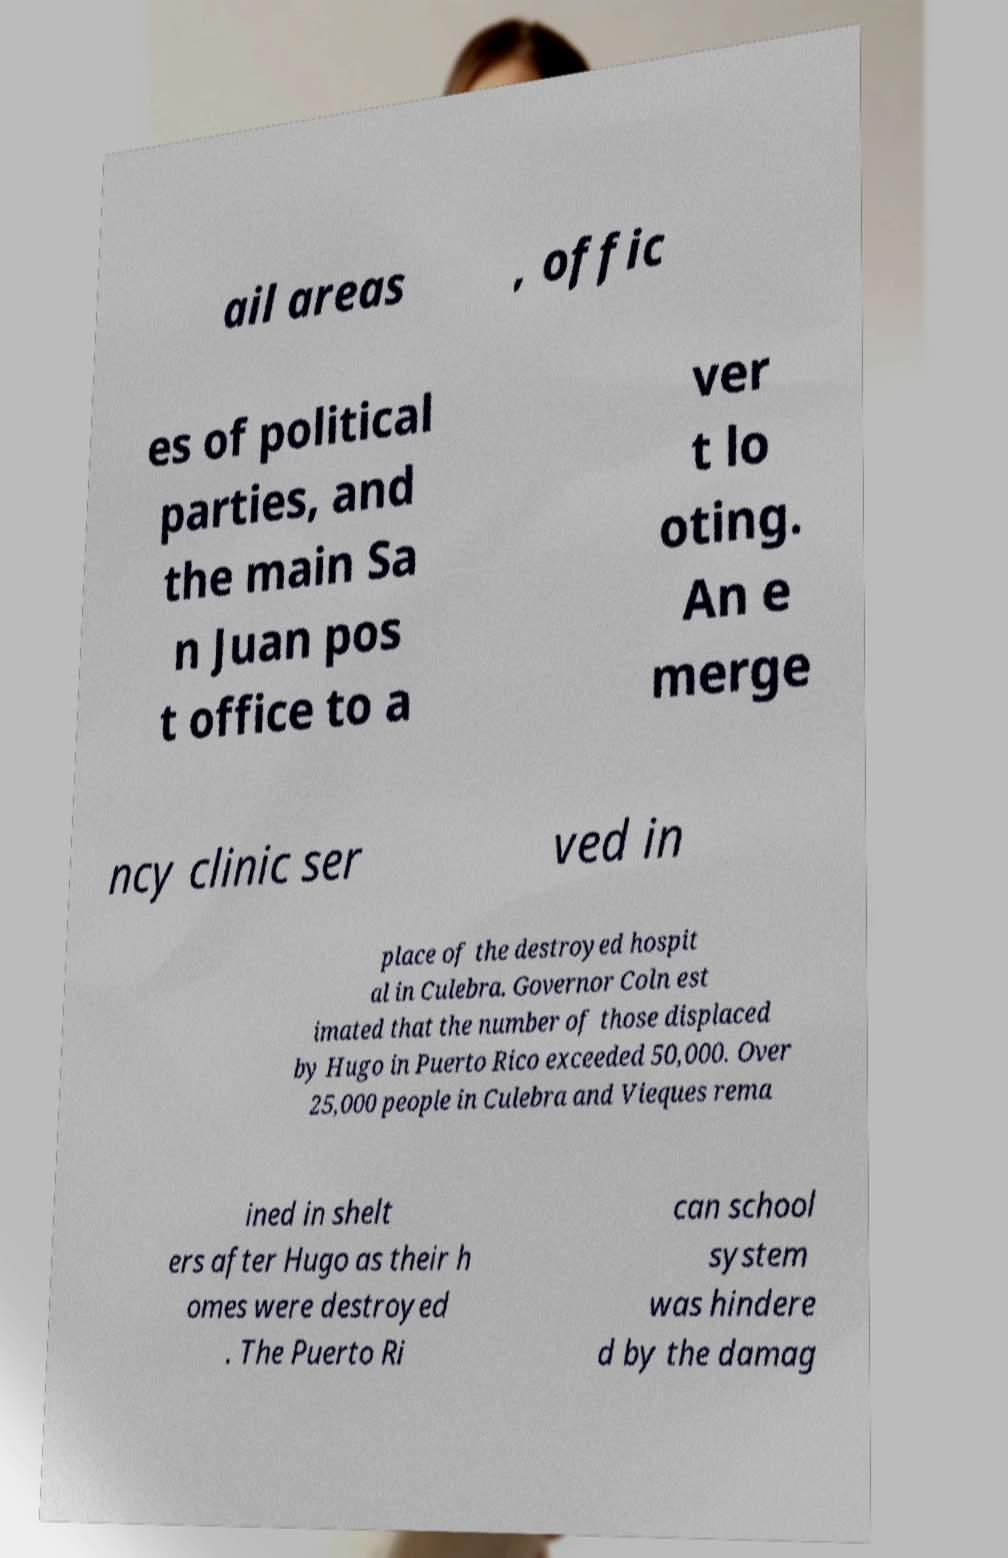Can you accurately transcribe the text from the provided image for me? ail areas , offic es of political parties, and the main Sa n Juan pos t office to a ver t lo oting. An e merge ncy clinic ser ved in place of the destroyed hospit al in Culebra. Governor Coln est imated that the number of those displaced by Hugo in Puerto Rico exceeded 50,000. Over 25,000 people in Culebra and Vieques rema ined in shelt ers after Hugo as their h omes were destroyed . The Puerto Ri can school system was hindere d by the damag 